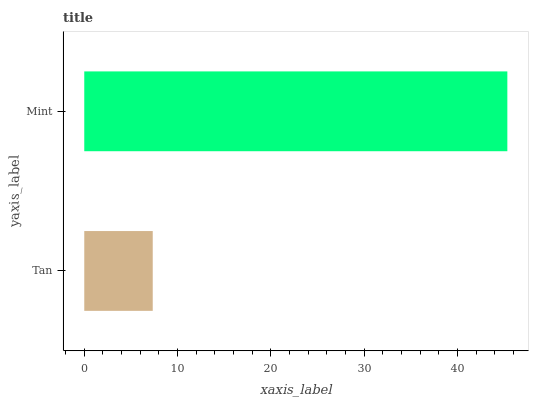Is Tan the minimum?
Answer yes or no. Yes. Is Mint the maximum?
Answer yes or no. Yes. Is Mint the minimum?
Answer yes or no. No. Is Mint greater than Tan?
Answer yes or no. Yes. Is Tan less than Mint?
Answer yes or no. Yes. Is Tan greater than Mint?
Answer yes or no. No. Is Mint less than Tan?
Answer yes or no. No. Is Mint the high median?
Answer yes or no. Yes. Is Tan the low median?
Answer yes or no. Yes. Is Tan the high median?
Answer yes or no. No. Is Mint the low median?
Answer yes or no. No. 